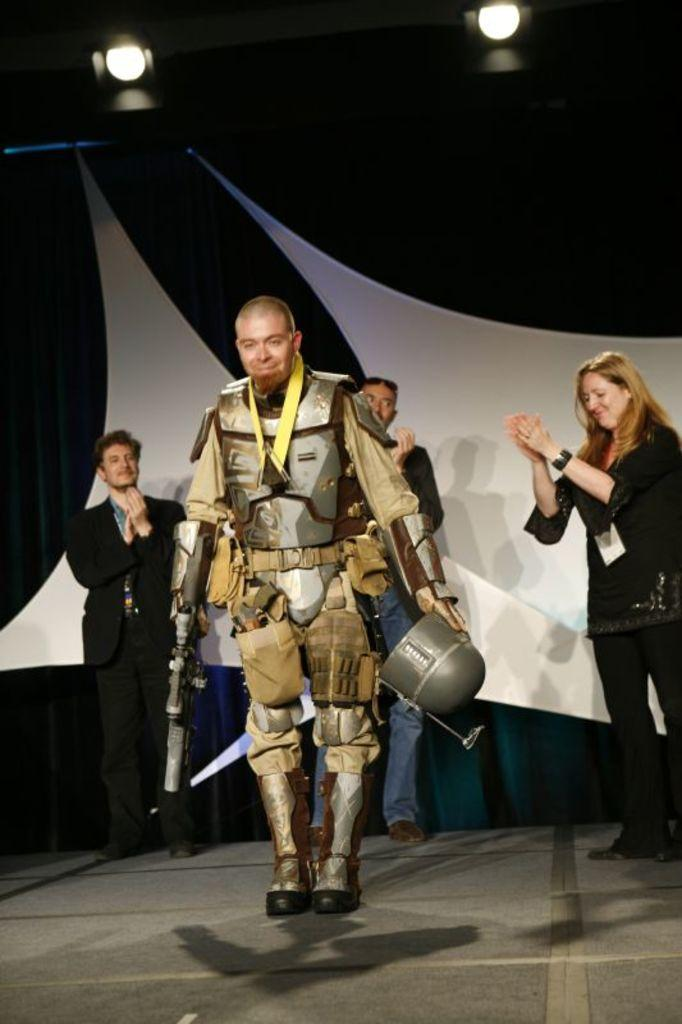What is the man in the image holding? The man is holding a gun and a helmet. What can be seen in the background of the image? There are persons and a curtain in the background of the image. What is located at the top of the image? There are lights at the top of the image. What is the rate of the potato growing in the image? There is no potato present in the image, so it is not possible to determine its growth rate. What type of apparatus is being used by the man in the image? The man is holding a gun and a helmet, but there is no apparatus mentioned in the facts. 